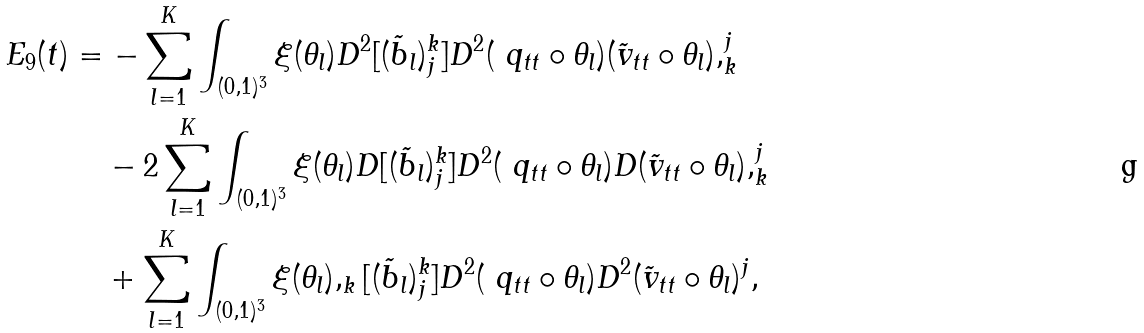<formula> <loc_0><loc_0><loc_500><loc_500>E _ { 9 } ( t ) & = - \sum _ { l = 1 } ^ { K } \int _ { ( 0 , 1 ) ^ { 3 } } \xi ( \theta _ { l } ) D ^ { 2 } [ ( \tilde { b } _ { l } ) _ { j } ^ { k } ] D ^ { 2 } ( \ q _ { t t } \circ \theta _ { l } ) ( { \tilde { v } } _ { t t } \circ \theta _ { l } ) , _ { k } ^ { j } \\ & \quad - 2 \sum _ { l = 1 } ^ { K } \int _ { ( 0 , 1 ) ^ { 3 } } \xi ( \theta _ { l } ) D [ ( \tilde { b } _ { l } ) _ { j } ^ { k } ] D ^ { 2 } ( \ q _ { t t } \circ \theta _ { l } ) D ( { \tilde { v } } _ { t t } \circ \theta _ { l } ) , _ { k } ^ { j } \\ & \quad + \sum _ { l = 1 } ^ { K } \int _ { ( 0 , 1 ) ^ { 3 } } \xi ( \theta _ { l } ) , _ { k } [ ( \tilde { b } _ { l } ) _ { j } ^ { k } ] D ^ { 2 } ( \ q _ { t t } \circ \theta _ { l } ) D ^ { 2 } ( { \tilde { v } } _ { t t } \circ \theta _ { l } ) ^ { j } ,</formula> 